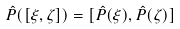<formula> <loc_0><loc_0><loc_500><loc_500>\hat { P } ( [ \xi , \zeta ] ) = [ \hat { P } ( \xi ) , \hat { P } ( \zeta ) ]</formula> 